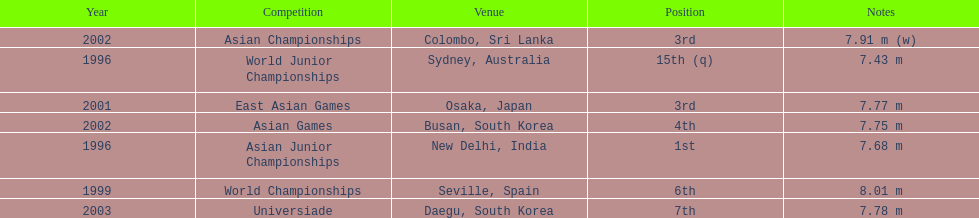How many times did his jump surpass 7.70 m? 5. 